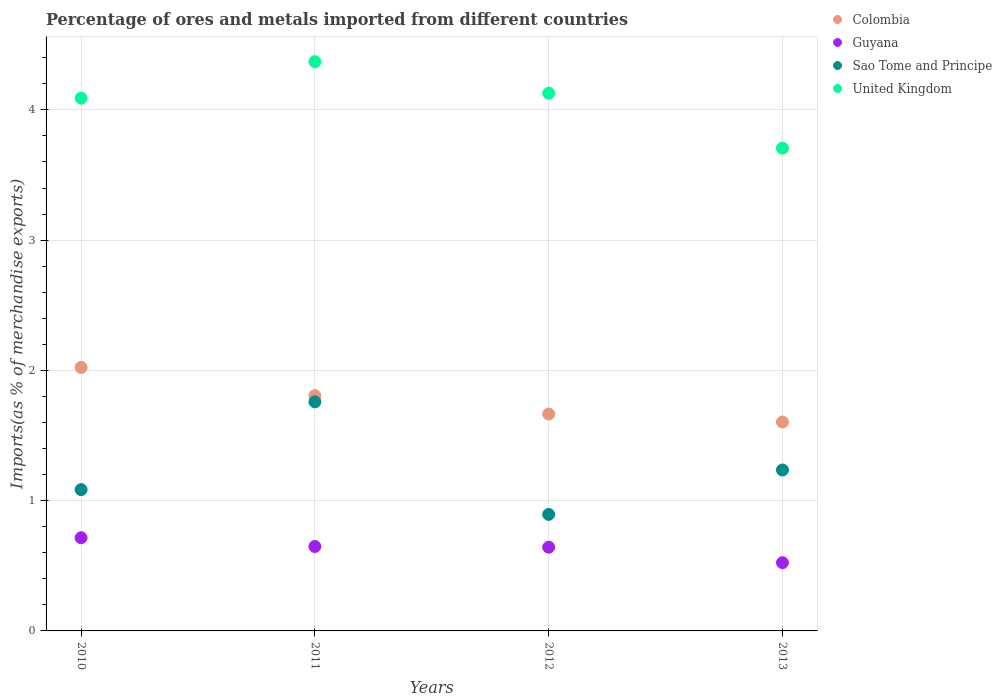What is the percentage of imports to different countries in Guyana in 2013?
Keep it short and to the point. 0.52. Across all years, what is the maximum percentage of imports to different countries in Guyana?
Your answer should be compact. 0.72. Across all years, what is the minimum percentage of imports to different countries in Guyana?
Keep it short and to the point. 0.52. In which year was the percentage of imports to different countries in United Kingdom maximum?
Offer a terse response. 2011. What is the total percentage of imports to different countries in United Kingdom in the graph?
Provide a succinct answer. 16.29. What is the difference between the percentage of imports to different countries in Sao Tome and Principe in 2010 and that in 2011?
Offer a terse response. -0.67. What is the difference between the percentage of imports to different countries in Sao Tome and Principe in 2011 and the percentage of imports to different countries in Colombia in 2012?
Your answer should be very brief. 0.09. What is the average percentage of imports to different countries in Guyana per year?
Ensure brevity in your answer.  0.63. In the year 2012, what is the difference between the percentage of imports to different countries in United Kingdom and percentage of imports to different countries in Sao Tome and Principe?
Keep it short and to the point. 3.23. In how many years, is the percentage of imports to different countries in Colombia greater than 1.6 %?
Offer a terse response. 4. What is the ratio of the percentage of imports to different countries in Sao Tome and Principe in 2010 to that in 2012?
Your response must be concise. 1.21. Is the percentage of imports to different countries in Sao Tome and Principe in 2011 less than that in 2013?
Provide a succinct answer. No. What is the difference between the highest and the second highest percentage of imports to different countries in Sao Tome and Principe?
Your response must be concise. 0.52. What is the difference between the highest and the lowest percentage of imports to different countries in United Kingdom?
Provide a short and direct response. 0.66. In how many years, is the percentage of imports to different countries in Sao Tome and Principe greater than the average percentage of imports to different countries in Sao Tome and Principe taken over all years?
Your answer should be compact. 1. Is the sum of the percentage of imports to different countries in United Kingdom in 2010 and 2012 greater than the maximum percentage of imports to different countries in Colombia across all years?
Provide a succinct answer. Yes. Does the percentage of imports to different countries in Sao Tome and Principe monotonically increase over the years?
Make the answer very short. No. Is the percentage of imports to different countries in United Kingdom strictly greater than the percentage of imports to different countries in Colombia over the years?
Keep it short and to the point. Yes. Is the percentage of imports to different countries in Sao Tome and Principe strictly less than the percentage of imports to different countries in Guyana over the years?
Give a very brief answer. No. How many dotlines are there?
Ensure brevity in your answer.  4. How many years are there in the graph?
Your answer should be very brief. 4. Does the graph contain any zero values?
Ensure brevity in your answer.  No. Does the graph contain grids?
Provide a succinct answer. Yes. How many legend labels are there?
Provide a succinct answer. 4. How are the legend labels stacked?
Give a very brief answer. Vertical. What is the title of the graph?
Make the answer very short. Percentage of ores and metals imported from different countries. Does "Algeria" appear as one of the legend labels in the graph?
Provide a short and direct response. No. What is the label or title of the Y-axis?
Your answer should be very brief. Imports(as % of merchandise exports). What is the Imports(as % of merchandise exports) of Colombia in 2010?
Offer a terse response. 2.02. What is the Imports(as % of merchandise exports) in Guyana in 2010?
Keep it short and to the point. 0.72. What is the Imports(as % of merchandise exports) of Sao Tome and Principe in 2010?
Your answer should be compact. 1.08. What is the Imports(as % of merchandise exports) of United Kingdom in 2010?
Your answer should be very brief. 4.09. What is the Imports(as % of merchandise exports) of Colombia in 2011?
Your response must be concise. 1.81. What is the Imports(as % of merchandise exports) of Guyana in 2011?
Offer a terse response. 0.65. What is the Imports(as % of merchandise exports) of Sao Tome and Principe in 2011?
Offer a very short reply. 1.76. What is the Imports(as % of merchandise exports) in United Kingdom in 2011?
Provide a short and direct response. 4.37. What is the Imports(as % of merchandise exports) in Colombia in 2012?
Your answer should be compact. 1.67. What is the Imports(as % of merchandise exports) in Guyana in 2012?
Provide a succinct answer. 0.64. What is the Imports(as % of merchandise exports) in Sao Tome and Principe in 2012?
Offer a terse response. 0.89. What is the Imports(as % of merchandise exports) in United Kingdom in 2012?
Provide a short and direct response. 4.13. What is the Imports(as % of merchandise exports) of Colombia in 2013?
Your answer should be very brief. 1.6. What is the Imports(as % of merchandise exports) in Guyana in 2013?
Ensure brevity in your answer.  0.52. What is the Imports(as % of merchandise exports) of Sao Tome and Principe in 2013?
Offer a terse response. 1.24. What is the Imports(as % of merchandise exports) in United Kingdom in 2013?
Offer a terse response. 3.71. Across all years, what is the maximum Imports(as % of merchandise exports) in Colombia?
Provide a short and direct response. 2.02. Across all years, what is the maximum Imports(as % of merchandise exports) of Guyana?
Offer a terse response. 0.72. Across all years, what is the maximum Imports(as % of merchandise exports) in Sao Tome and Principe?
Keep it short and to the point. 1.76. Across all years, what is the maximum Imports(as % of merchandise exports) in United Kingdom?
Ensure brevity in your answer.  4.37. Across all years, what is the minimum Imports(as % of merchandise exports) in Colombia?
Give a very brief answer. 1.6. Across all years, what is the minimum Imports(as % of merchandise exports) of Guyana?
Offer a very short reply. 0.52. Across all years, what is the minimum Imports(as % of merchandise exports) in Sao Tome and Principe?
Offer a terse response. 0.89. Across all years, what is the minimum Imports(as % of merchandise exports) of United Kingdom?
Offer a very short reply. 3.71. What is the total Imports(as % of merchandise exports) of Colombia in the graph?
Ensure brevity in your answer.  7.1. What is the total Imports(as % of merchandise exports) of Guyana in the graph?
Offer a terse response. 2.53. What is the total Imports(as % of merchandise exports) in Sao Tome and Principe in the graph?
Your response must be concise. 4.97. What is the total Imports(as % of merchandise exports) of United Kingdom in the graph?
Your answer should be compact. 16.29. What is the difference between the Imports(as % of merchandise exports) of Colombia in 2010 and that in 2011?
Your answer should be compact. 0.22. What is the difference between the Imports(as % of merchandise exports) of Guyana in 2010 and that in 2011?
Give a very brief answer. 0.07. What is the difference between the Imports(as % of merchandise exports) of Sao Tome and Principe in 2010 and that in 2011?
Your answer should be very brief. -0.67. What is the difference between the Imports(as % of merchandise exports) of United Kingdom in 2010 and that in 2011?
Your answer should be very brief. -0.28. What is the difference between the Imports(as % of merchandise exports) of Colombia in 2010 and that in 2012?
Provide a short and direct response. 0.36. What is the difference between the Imports(as % of merchandise exports) of Guyana in 2010 and that in 2012?
Make the answer very short. 0.07. What is the difference between the Imports(as % of merchandise exports) in Sao Tome and Principe in 2010 and that in 2012?
Provide a succinct answer. 0.19. What is the difference between the Imports(as % of merchandise exports) in United Kingdom in 2010 and that in 2012?
Keep it short and to the point. -0.04. What is the difference between the Imports(as % of merchandise exports) of Colombia in 2010 and that in 2013?
Ensure brevity in your answer.  0.42. What is the difference between the Imports(as % of merchandise exports) of Guyana in 2010 and that in 2013?
Offer a terse response. 0.19. What is the difference between the Imports(as % of merchandise exports) of Sao Tome and Principe in 2010 and that in 2013?
Make the answer very short. -0.15. What is the difference between the Imports(as % of merchandise exports) in United Kingdom in 2010 and that in 2013?
Offer a terse response. 0.38. What is the difference between the Imports(as % of merchandise exports) in Colombia in 2011 and that in 2012?
Give a very brief answer. 0.14. What is the difference between the Imports(as % of merchandise exports) in Guyana in 2011 and that in 2012?
Provide a short and direct response. 0.01. What is the difference between the Imports(as % of merchandise exports) of Sao Tome and Principe in 2011 and that in 2012?
Provide a succinct answer. 0.86. What is the difference between the Imports(as % of merchandise exports) of United Kingdom in 2011 and that in 2012?
Give a very brief answer. 0.24. What is the difference between the Imports(as % of merchandise exports) of Colombia in 2011 and that in 2013?
Give a very brief answer. 0.2. What is the difference between the Imports(as % of merchandise exports) of Guyana in 2011 and that in 2013?
Provide a short and direct response. 0.12. What is the difference between the Imports(as % of merchandise exports) in Sao Tome and Principe in 2011 and that in 2013?
Give a very brief answer. 0.52. What is the difference between the Imports(as % of merchandise exports) in United Kingdom in 2011 and that in 2013?
Make the answer very short. 0.66. What is the difference between the Imports(as % of merchandise exports) of Colombia in 2012 and that in 2013?
Provide a succinct answer. 0.06. What is the difference between the Imports(as % of merchandise exports) in Guyana in 2012 and that in 2013?
Provide a succinct answer. 0.12. What is the difference between the Imports(as % of merchandise exports) of Sao Tome and Principe in 2012 and that in 2013?
Provide a succinct answer. -0.34. What is the difference between the Imports(as % of merchandise exports) in United Kingdom in 2012 and that in 2013?
Offer a terse response. 0.42. What is the difference between the Imports(as % of merchandise exports) in Colombia in 2010 and the Imports(as % of merchandise exports) in Guyana in 2011?
Give a very brief answer. 1.37. What is the difference between the Imports(as % of merchandise exports) of Colombia in 2010 and the Imports(as % of merchandise exports) of Sao Tome and Principe in 2011?
Make the answer very short. 0.26. What is the difference between the Imports(as % of merchandise exports) of Colombia in 2010 and the Imports(as % of merchandise exports) of United Kingdom in 2011?
Keep it short and to the point. -2.35. What is the difference between the Imports(as % of merchandise exports) of Guyana in 2010 and the Imports(as % of merchandise exports) of Sao Tome and Principe in 2011?
Give a very brief answer. -1.04. What is the difference between the Imports(as % of merchandise exports) in Guyana in 2010 and the Imports(as % of merchandise exports) in United Kingdom in 2011?
Keep it short and to the point. -3.65. What is the difference between the Imports(as % of merchandise exports) of Sao Tome and Principe in 2010 and the Imports(as % of merchandise exports) of United Kingdom in 2011?
Keep it short and to the point. -3.29. What is the difference between the Imports(as % of merchandise exports) of Colombia in 2010 and the Imports(as % of merchandise exports) of Guyana in 2012?
Offer a terse response. 1.38. What is the difference between the Imports(as % of merchandise exports) in Colombia in 2010 and the Imports(as % of merchandise exports) in Sao Tome and Principe in 2012?
Offer a terse response. 1.13. What is the difference between the Imports(as % of merchandise exports) in Colombia in 2010 and the Imports(as % of merchandise exports) in United Kingdom in 2012?
Your answer should be very brief. -2.1. What is the difference between the Imports(as % of merchandise exports) in Guyana in 2010 and the Imports(as % of merchandise exports) in Sao Tome and Principe in 2012?
Ensure brevity in your answer.  -0.18. What is the difference between the Imports(as % of merchandise exports) in Guyana in 2010 and the Imports(as % of merchandise exports) in United Kingdom in 2012?
Make the answer very short. -3.41. What is the difference between the Imports(as % of merchandise exports) of Sao Tome and Principe in 2010 and the Imports(as % of merchandise exports) of United Kingdom in 2012?
Provide a short and direct response. -3.04. What is the difference between the Imports(as % of merchandise exports) of Colombia in 2010 and the Imports(as % of merchandise exports) of Guyana in 2013?
Provide a succinct answer. 1.5. What is the difference between the Imports(as % of merchandise exports) in Colombia in 2010 and the Imports(as % of merchandise exports) in Sao Tome and Principe in 2013?
Provide a short and direct response. 0.79. What is the difference between the Imports(as % of merchandise exports) in Colombia in 2010 and the Imports(as % of merchandise exports) in United Kingdom in 2013?
Make the answer very short. -1.68. What is the difference between the Imports(as % of merchandise exports) in Guyana in 2010 and the Imports(as % of merchandise exports) in Sao Tome and Principe in 2013?
Keep it short and to the point. -0.52. What is the difference between the Imports(as % of merchandise exports) in Guyana in 2010 and the Imports(as % of merchandise exports) in United Kingdom in 2013?
Ensure brevity in your answer.  -2.99. What is the difference between the Imports(as % of merchandise exports) of Sao Tome and Principe in 2010 and the Imports(as % of merchandise exports) of United Kingdom in 2013?
Offer a terse response. -2.62. What is the difference between the Imports(as % of merchandise exports) in Colombia in 2011 and the Imports(as % of merchandise exports) in Guyana in 2012?
Offer a very short reply. 1.16. What is the difference between the Imports(as % of merchandise exports) of Colombia in 2011 and the Imports(as % of merchandise exports) of Sao Tome and Principe in 2012?
Your response must be concise. 0.91. What is the difference between the Imports(as % of merchandise exports) in Colombia in 2011 and the Imports(as % of merchandise exports) in United Kingdom in 2012?
Ensure brevity in your answer.  -2.32. What is the difference between the Imports(as % of merchandise exports) in Guyana in 2011 and the Imports(as % of merchandise exports) in Sao Tome and Principe in 2012?
Your answer should be very brief. -0.25. What is the difference between the Imports(as % of merchandise exports) in Guyana in 2011 and the Imports(as % of merchandise exports) in United Kingdom in 2012?
Provide a short and direct response. -3.48. What is the difference between the Imports(as % of merchandise exports) in Sao Tome and Principe in 2011 and the Imports(as % of merchandise exports) in United Kingdom in 2012?
Give a very brief answer. -2.37. What is the difference between the Imports(as % of merchandise exports) of Colombia in 2011 and the Imports(as % of merchandise exports) of Guyana in 2013?
Offer a very short reply. 1.28. What is the difference between the Imports(as % of merchandise exports) in Colombia in 2011 and the Imports(as % of merchandise exports) in Sao Tome and Principe in 2013?
Give a very brief answer. 0.57. What is the difference between the Imports(as % of merchandise exports) of Colombia in 2011 and the Imports(as % of merchandise exports) of United Kingdom in 2013?
Make the answer very short. -1.9. What is the difference between the Imports(as % of merchandise exports) of Guyana in 2011 and the Imports(as % of merchandise exports) of Sao Tome and Principe in 2013?
Make the answer very short. -0.59. What is the difference between the Imports(as % of merchandise exports) of Guyana in 2011 and the Imports(as % of merchandise exports) of United Kingdom in 2013?
Ensure brevity in your answer.  -3.06. What is the difference between the Imports(as % of merchandise exports) in Sao Tome and Principe in 2011 and the Imports(as % of merchandise exports) in United Kingdom in 2013?
Keep it short and to the point. -1.95. What is the difference between the Imports(as % of merchandise exports) of Colombia in 2012 and the Imports(as % of merchandise exports) of Guyana in 2013?
Offer a very short reply. 1.14. What is the difference between the Imports(as % of merchandise exports) in Colombia in 2012 and the Imports(as % of merchandise exports) in Sao Tome and Principe in 2013?
Your response must be concise. 0.43. What is the difference between the Imports(as % of merchandise exports) in Colombia in 2012 and the Imports(as % of merchandise exports) in United Kingdom in 2013?
Your answer should be compact. -2.04. What is the difference between the Imports(as % of merchandise exports) of Guyana in 2012 and the Imports(as % of merchandise exports) of Sao Tome and Principe in 2013?
Your answer should be compact. -0.59. What is the difference between the Imports(as % of merchandise exports) of Guyana in 2012 and the Imports(as % of merchandise exports) of United Kingdom in 2013?
Offer a terse response. -3.06. What is the difference between the Imports(as % of merchandise exports) in Sao Tome and Principe in 2012 and the Imports(as % of merchandise exports) in United Kingdom in 2013?
Your answer should be compact. -2.81. What is the average Imports(as % of merchandise exports) in Colombia per year?
Make the answer very short. 1.77. What is the average Imports(as % of merchandise exports) in Guyana per year?
Provide a succinct answer. 0.63. What is the average Imports(as % of merchandise exports) of Sao Tome and Principe per year?
Offer a terse response. 1.24. What is the average Imports(as % of merchandise exports) of United Kingdom per year?
Offer a very short reply. 4.07. In the year 2010, what is the difference between the Imports(as % of merchandise exports) in Colombia and Imports(as % of merchandise exports) in Guyana?
Keep it short and to the point. 1.31. In the year 2010, what is the difference between the Imports(as % of merchandise exports) in Colombia and Imports(as % of merchandise exports) in Sao Tome and Principe?
Offer a very short reply. 0.94. In the year 2010, what is the difference between the Imports(as % of merchandise exports) in Colombia and Imports(as % of merchandise exports) in United Kingdom?
Your response must be concise. -2.07. In the year 2010, what is the difference between the Imports(as % of merchandise exports) of Guyana and Imports(as % of merchandise exports) of Sao Tome and Principe?
Your answer should be compact. -0.37. In the year 2010, what is the difference between the Imports(as % of merchandise exports) in Guyana and Imports(as % of merchandise exports) in United Kingdom?
Offer a terse response. -3.37. In the year 2010, what is the difference between the Imports(as % of merchandise exports) in Sao Tome and Principe and Imports(as % of merchandise exports) in United Kingdom?
Provide a short and direct response. -3.01. In the year 2011, what is the difference between the Imports(as % of merchandise exports) of Colombia and Imports(as % of merchandise exports) of Guyana?
Your answer should be very brief. 1.16. In the year 2011, what is the difference between the Imports(as % of merchandise exports) in Colombia and Imports(as % of merchandise exports) in Sao Tome and Principe?
Your answer should be very brief. 0.05. In the year 2011, what is the difference between the Imports(as % of merchandise exports) of Colombia and Imports(as % of merchandise exports) of United Kingdom?
Your answer should be very brief. -2.56. In the year 2011, what is the difference between the Imports(as % of merchandise exports) in Guyana and Imports(as % of merchandise exports) in Sao Tome and Principe?
Your response must be concise. -1.11. In the year 2011, what is the difference between the Imports(as % of merchandise exports) of Guyana and Imports(as % of merchandise exports) of United Kingdom?
Your answer should be compact. -3.72. In the year 2011, what is the difference between the Imports(as % of merchandise exports) in Sao Tome and Principe and Imports(as % of merchandise exports) in United Kingdom?
Offer a terse response. -2.61. In the year 2012, what is the difference between the Imports(as % of merchandise exports) of Colombia and Imports(as % of merchandise exports) of Guyana?
Offer a very short reply. 1.02. In the year 2012, what is the difference between the Imports(as % of merchandise exports) in Colombia and Imports(as % of merchandise exports) in Sao Tome and Principe?
Your answer should be compact. 0.77. In the year 2012, what is the difference between the Imports(as % of merchandise exports) of Colombia and Imports(as % of merchandise exports) of United Kingdom?
Ensure brevity in your answer.  -2.46. In the year 2012, what is the difference between the Imports(as % of merchandise exports) of Guyana and Imports(as % of merchandise exports) of Sao Tome and Principe?
Give a very brief answer. -0.25. In the year 2012, what is the difference between the Imports(as % of merchandise exports) of Guyana and Imports(as % of merchandise exports) of United Kingdom?
Offer a terse response. -3.49. In the year 2012, what is the difference between the Imports(as % of merchandise exports) of Sao Tome and Principe and Imports(as % of merchandise exports) of United Kingdom?
Your answer should be compact. -3.23. In the year 2013, what is the difference between the Imports(as % of merchandise exports) of Colombia and Imports(as % of merchandise exports) of Sao Tome and Principe?
Your response must be concise. 0.37. In the year 2013, what is the difference between the Imports(as % of merchandise exports) of Colombia and Imports(as % of merchandise exports) of United Kingdom?
Your answer should be compact. -2.1. In the year 2013, what is the difference between the Imports(as % of merchandise exports) in Guyana and Imports(as % of merchandise exports) in Sao Tome and Principe?
Keep it short and to the point. -0.71. In the year 2013, what is the difference between the Imports(as % of merchandise exports) in Guyana and Imports(as % of merchandise exports) in United Kingdom?
Make the answer very short. -3.18. In the year 2013, what is the difference between the Imports(as % of merchandise exports) of Sao Tome and Principe and Imports(as % of merchandise exports) of United Kingdom?
Keep it short and to the point. -2.47. What is the ratio of the Imports(as % of merchandise exports) in Colombia in 2010 to that in 2011?
Provide a succinct answer. 1.12. What is the ratio of the Imports(as % of merchandise exports) of Guyana in 2010 to that in 2011?
Provide a short and direct response. 1.1. What is the ratio of the Imports(as % of merchandise exports) in Sao Tome and Principe in 2010 to that in 2011?
Provide a succinct answer. 0.62. What is the ratio of the Imports(as % of merchandise exports) in United Kingdom in 2010 to that in 2011?
Give a very brief answer. 0.94. What is the ratio of the Imports(as % of merchandise exports) of Colombia in 2010 to that in 2012?
Provide a succinct answer. 1.21. What is the ratio of the Imports(as % of merchandise exports) of Guyana in 2010 to that in 2012?
Keep it short and to the point. 1.11. What is the ratio of the Imports(as % of merchandise exports) of Sao Tome and Principe in 2010 to that in 2012?
Offer a very short reply. 1.21. What is the ratio of the Imports(as % of merchandise exports) in United Kingdom in 2010 to that in 2012?
Give a very brief answer. 0.99. What is the ratio of the Imports(as % of merchandise exports) of Colombia in 2010 to that in 2013?
Your answer should be very brief. 1.26. What is the ratio of the Imports(as % of merchandise exports) of Guyana in 2010 to that in 2013?
Give a very brief answer. 1.37. What is the ratio of the Imports(as % of merchandise exports) of Sao Tome and Principe in 2010 to that in 2013?
Provide a succinct answer. 0.88. What is the ratio of the Imports(as % of merchandise exports) in United Kingdom in 2010 to that in 2013?
Your answer should be compact. 1.1. What is the ratio of the Imports(as % of merchandise exports) of Colombia in 2011 to that in 2012?
Make the answer very short. 1.08. What is the ratio of the Imports(as % of merchandise exports) of Guyana in 2011 to that in 2012?
Provide a succinct answer. 1.01. What is the ratio of the Imports(as % of merchandise exports) in Sao Tome and Principe in 2011 to that in 2012?
Ensure brevity in your answer.  1.97. What is the ratio of the Imports(as % of merchandise exports) of United Kingdom in 2011 to that in 2012?
Your answer should be very brief. 1.06. What is the ratio of the Imports(as % of merchandise exports) in Colombia in 2011 to that in 2013?
Give a very brief answer. 1.13. What is the ratio of the Imports(as % of merchandise exports) in Guyana in 2011 to that in 2013?
Ensure brevity in your answer.  1.24. What is the ratio of the Imports(as % of merchandise exports) of Sao Tome and Principe in 2011 to that in 2013?
Give a very brief answer. 1.42. What is the ratio of the Imports(as % of merchandise exports) in United Kingdom in 2011 to that in 2013?
Your answer should be compact. 1.18. What is the ratio of the Imports(as % of merchandise exports) of Colombia in 2012 to that in 2013?
Make the answer very short. 1.04. What is the ratio of the Imports(as % of merchandise exports) of Guyana in 2012 to that in 2013?
Offer a very short reply. 1.23. What is the ratio of the Imports(as % of merchandise exports) of Sao Tome and Principe in 2012 to that in 2013?
Ensure brevity in your answer.  0.72. What is the ratio of the Imports(as % of merchandise exports) in United Kingdom in 2012 to that in 2013?
Make the answer very short. 1.11. What is the difference between the highest and the second highest Imports(as % of merchandise exports) in Colombia?
Provide a short and direct response. 0.22. What is the difference between the highest and the second highest Imports(as % of merchandise exports) of Guyana?
Keep it short and to the point. 0.07. What is the difference between the highest and the second highest Imports(as % of merchandise exports) in Sao Tome and Principe?
Your response must be concise. 0.52. What is the difference between the highest and the second highest Imports(as % of merchandise exports) in United Kingdom?
Provide a short and direct response. 0.24. What is the difference between the highest and the lowest Imports(as % of merchandise exports) of Colombia?
Make the answer very short. 0.42. What is the difference between the highest and the lowest Imports(as % of merchandise exports) of Guyana?
Offer a terse response. 0.19. What is the difference between the highest and the lowest Imports(as % of merchandise exports) of Sao Tome and Principe?
Your response must be concise. 0.86. What is the difference between the highest and the lowest Imports(as % of merchandise exports) of United Kingdom?
Your answer should be very brief. 0.66. 